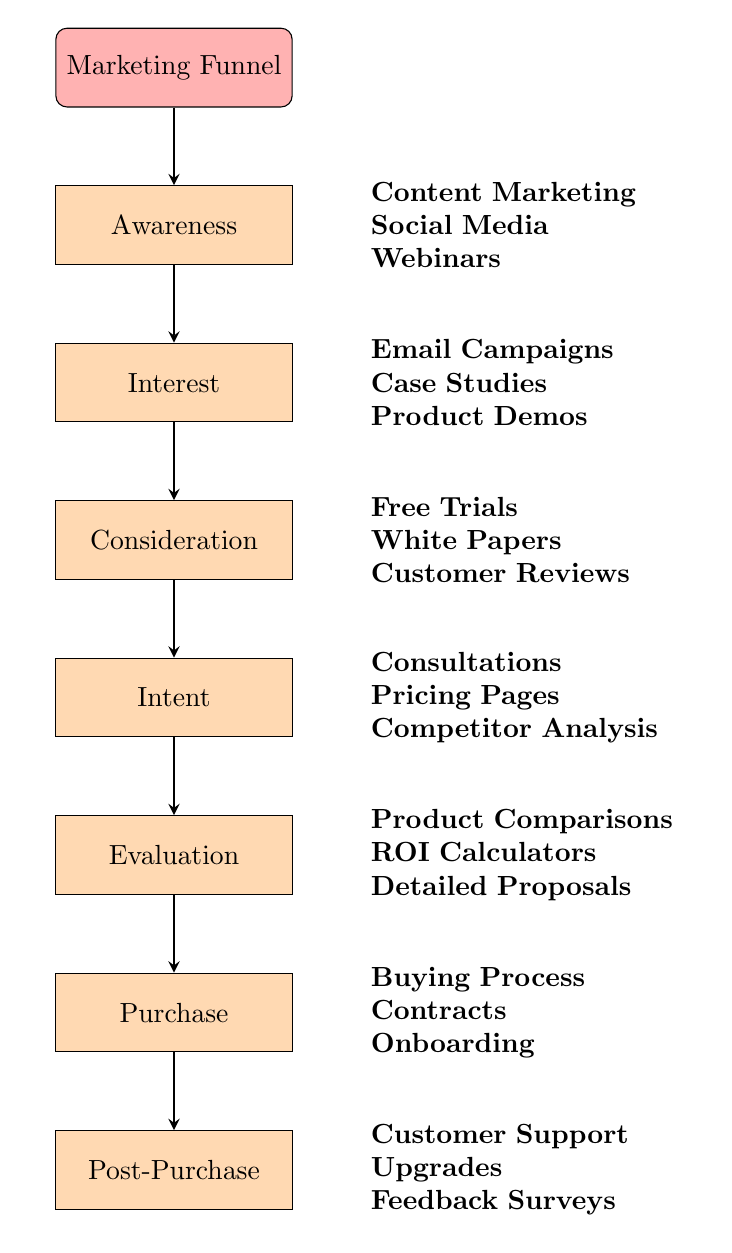What are the stages in the marketing funnel? The diagram lists seven stages from top to bottom: Awareness, Interest, Consideration, Intent, Evaluation, Purchase, and Post-Purchase.
Answer: Awareness, Interest, Consideration, Intent, Evaluation, Purchase, Post-Purchase What type of marketing activity is shown in the Awareness stage? In the Awareness stage, the activities are: Content Marketing, Social Media, and Webinars.
Answer: Content Marketing, Social Media, Webinars How many stages are there in the marketing funnel? By counting the nodes in the diagram, there are a total of seven distinct stages listed.
Answer: Seven What activities are included in the Intent stage? The Intent stage includes: Consultations, Pricing Pages, and Competitor Analysis.
Answer: Consultations, Pricing Pages, Competitor Analysis Which stage follows Evaluation? The diagram indicates that the Purchase stage follows immediately after the Evaluation stage.
Answer: Purchase Which activities are focused on customer feedback? In the Post-Purchase stage, the activities focused on customer feedback are Customer Support, Upgrades, and Feedback Surveys.
Answer: Feedback Surveys How many marketing strategies are listed for the Interest stage? Three specific marketing strategies are provided for the Interest stage: Email Campaigns, Case Studies, and Product Demos.
Answer: Three In which stage would you find Free Trials as an activity? Free Trials are listed as an activity within the Consideration stage of the marketing funnel.
Answer: Consideration What is the relationship between the Consideration and Intent stages? The diagram shows that the Intent stage directly follows the Consideration stage, indicating a progression in the marketing funnel.
Answer: Intent follows Consideration 